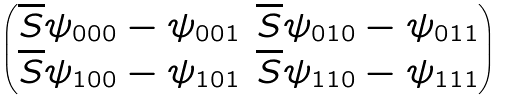<formula> <loc_0><loc_0><loc_500><loc_500>\begin{pmatrix} \overline { S } { \psi } _ { 0 0 0 } - { \psi } _ { 0 0 1 } & \overline { S } { \psi } _ { 0 1 0 } - { \psi } _ { 0 1 1 } \\ \overline { S } { \psi } _ { 1 0 0 } - { \psi } _ { 1 0 1 } & \overline { S } { \psi } _ { 1 1 0 } - { \psi } _ { 1 1 1 } \end{pmatrix}</formula> 